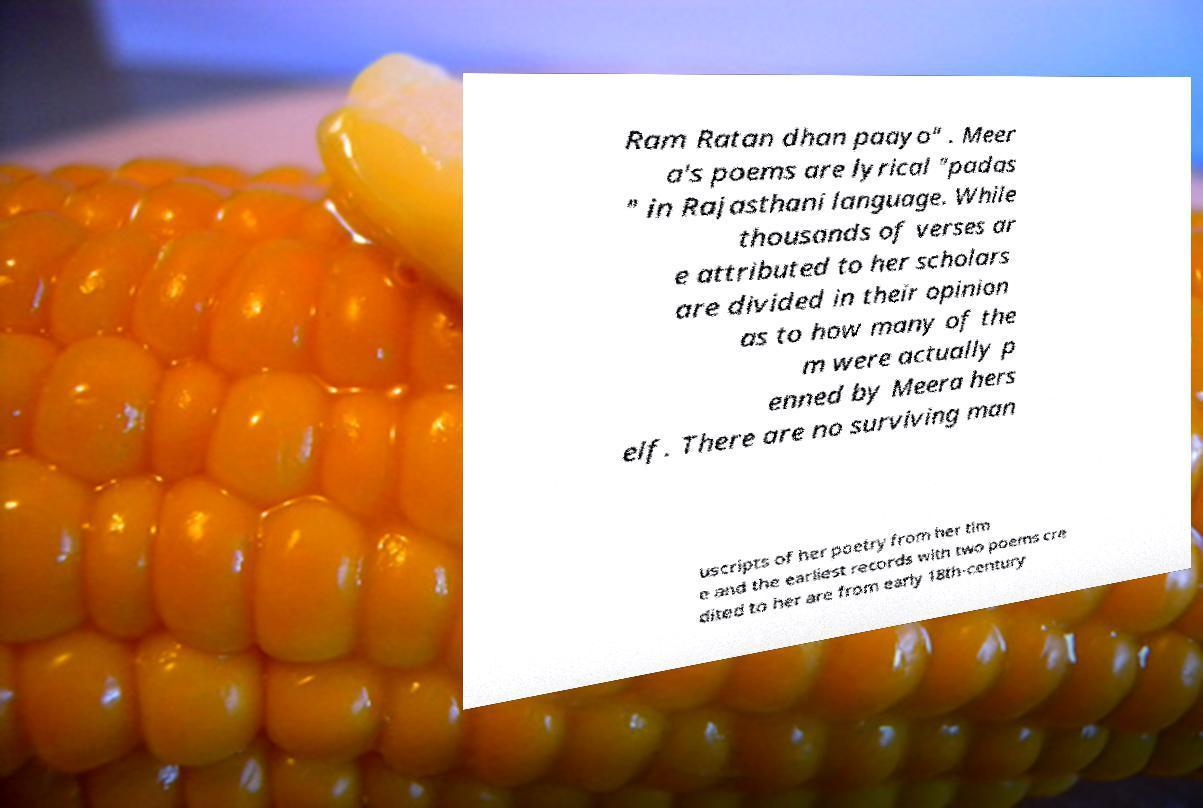Can you accurately transcribe the text from the provided image for me? Ram Ratan dhan paayo" . Meer a's poems are lyrical "padas " in Rajasthani language. While thousands of verses ar e attributed to her scholars are divided in their opinion as to how many of the m were actually p enned by Meera hers elf. There are no surviving man uscripts of her poetry from her tim e and the earliest records with two poems cre dited to her are from early 18th-century 